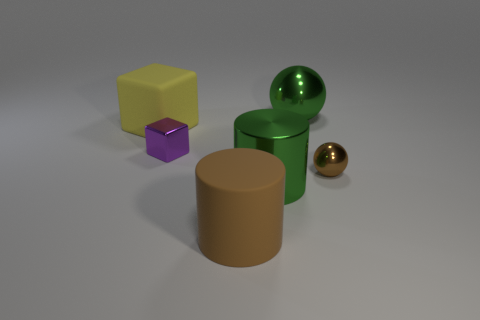Is there any object in the image that reflects light much like a mirror would? Yes, both the green and the small golden spheres have reflective surfaces, similar to a mirror, which you can tell by the way they catch the light and reflect their surroundings. 